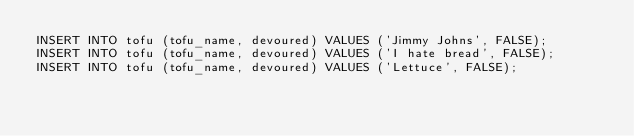Convert code to text. <code><loc_0><loc_0><loc_500><loc_500><_SQL_>INSERT INTO tofu (tofu_name, devoured) VALUES ('Jimmy Johns', FALSE);
INSERT INTO tofu (tofu_name, devoured) VALUES ('I hate bread', FALSE);
INSERT INTO tofu (tofu_name, devoured) VALUES ('Lettuce', FALSE);</code> 